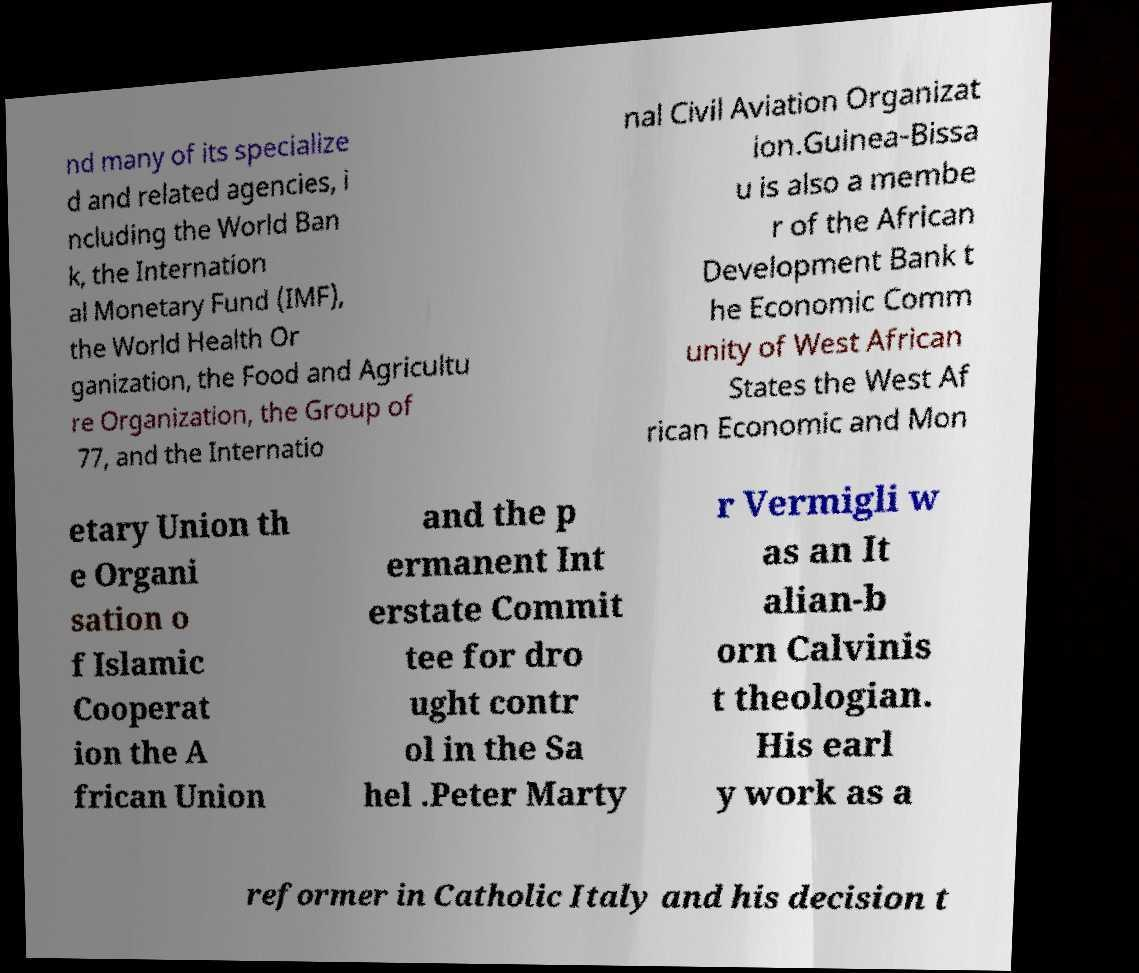I need the written content from this picture converted into text. Can you do that? nd many of its specialize d and related agencies, i ncluding the World Ban k, the Internation al Monetary Fund (IMF), the World Health Or ganization, the Food and Agricultu re Organization, the Group of 77, and the Internatio nal Civil Aviation Organizat ion.Guinea-Bissa u is also a membe r of the African Development Bank t he Economic Comm unity of West African States the West Af rican Economic and Mon etary Union th e Organi sation o f Islamic Cooperat ion the A frican Union and the p ermanent Int erstate Commit tee for dro ught contr ol in the Sa hel .Peter Marty r Vermigli w as an It alian-b orn Calvinis t theologian. His earl y work as a reformer in Catholic Italy and his decision t 